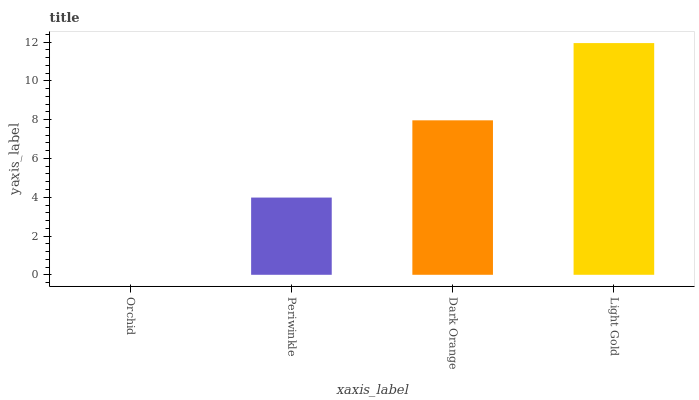Is Orchid the minimum?
Answer yes or no. Yes. Is Light Gold the maximum?
Answer yes or no. Yes. Is Periwinkle the minimum?
Answer yes or no. No. Is Periwinkle the maximum?
Answer yes or no. No. Is Periwinkle greater than Orchid?
Answer yes or no. Yes. Is Orchid less than Periwinkle?
Answer yes or no. Yes. Is Orchid greater than Periwinkle?
Answer yes or no. No. Is Periwinkle less than Orchid?
Answer yes or no. No. Is Dark Orange the high median?
Answer yes or no. Yes. Is Periwinkle the low median?
Answer yes or no. Yes. Is Orchid the high median?
Answer yes or no. No. Is Dark Orange the low median?
Answer yes or no. No. 